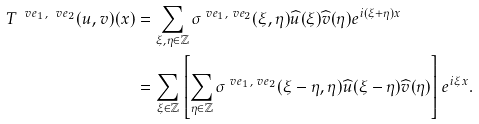Convert formula to latex. <formula><loc_0><loc_0><loc_500><loc_500>T ^ { \ v e _ { 1 } , \ v e _ { 2 } } ( u , v ) ( x ) & = \sum _ { \xi , \eta \in \mathbb { Z } } \sigma ^ { \ v e _ { 1 } , \ v e _ { 2 } } ( \xi , \eta ) \widehat { u } ( \xi ) \widehat { v } ( \eta ) e ^ { i ( \xi + \eta ) x } \\ & = \sum _ { \xi \in \mathbb { Z } } \left [ \sum _ { \eta \in \mathbb { Z } } \sigma ^ { \ v e _ { 1 } , \ v e _ { 2 } } ( \xi - \eta , \eta ) \widehat { u } ( \xi - \eta ) \widehat { v } ( \eta ) \right ] e ^ { i \xi x } .</formula> 